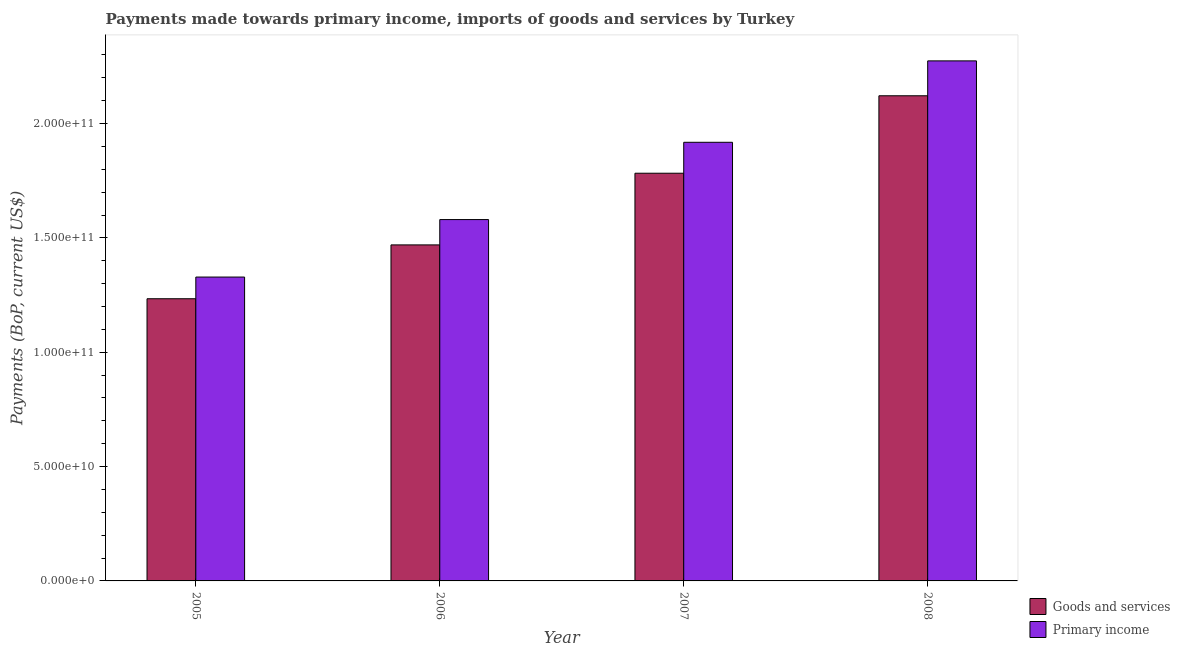How many different coloured bars are there?
Your answer should be compact. 2. How many groups of bars are there?
Make the answer very short. 4. Are the number of bars per tick equal to the number of legend labels?
Ensure brevity in your answer.  Yes. Are the number of bars on each tick of the X-axis equal?
Keep it short and to the point. Yes. How many bars are there on the 1st tick from the left?
Ensure brevity in your answer.  2. What is the label of the 3rd group of bars from the left?
Offer a terse response. 2007. What is the payments made towards goods and services in 2006?
Your answer should be very brief. 1.47e+11. Across all years, what is the maximum payments made towards primary income?
Offer a very short reply. 2.27e+11. Across all years, what is the minimum payments made towards goods and services?
Ensure brevity in your answer.  1.23e+11. In which year was the payments made towards goods and services maximum?
Provide a short and direct response. 2008. What is the total payments made towards primary income in the graph?
Provide a short and direct response. 7.10e+11. What is the difference between the payments made towards primary income in 2005 and that in 2006?
Make the answer very short. -2.51e+1. What is the difference between the payments made towards goods and services in 2006 and the payments made towards primary income in 2007?
Your answer should be compact. -3.13e+1. What is the average payments made towards goods and services per year?
Your answer should be compact. 1.65e+11. In how many years, is the payments made towards goods and services greater than 20000000000 US$?
Your response must be concise. 4. What is the ratio of the payments made towards primary income in 2005 to that in 2008?
Your response must be concise. 0.58. Is the payments made towards primary income in 2005 less than that in 2006?
Offer a terse response. Yes. Is the difference between the payments made towards goods and services in 2006 and 2007 greater than the difference between the payments made towards primary income in 2006 and 2007?
Keep it short and to the point. No. What is the difference between the highest and the second highest payments made towards primary income?
Ensure brevity in your answer.  3.56e+1. What is the difference between the highest and the lowest payments made towards primary income?
Your answer should be compact. 9.45e+1. In how many years, is the payments made towards goods and services greater than the average payments made towards goods and services taken over all years?
Your response must be concise. 2. Is the sum of the payments made towards goods and services in 2006 and 2007 greater than the maximum payments made towards primary income across all years?
Give a very brief answer. Yes. What does the 1st bar from the left in 2008 represents?
Give a very brief answer. Goods and services. What does the 2nd bar from the right in 2007 represents?
Make the answer very short. Goods and services. How many bars are there?
Keep it short and to the point. 8. How many years are there in the graph?
Offer a very short reply. 4. Are the values on the major ticks of Y-axis written in scientific E-notation?
Give a very brief answer. Yes. Does the graph contain grids?
Keep it short and to the point. No. Where does the legend appear in the graph?
Your answer should be very brief. Bottom right. How many legend labels are there?
Your response must be concise. 2. How are the legend labels stacked?
Provide a short and direct response. Vertical. What is the title of the graph?
Your answer should be compact. Payments made towards primary income, imports of goods and services by Turkey. What is the label or title of the Y-axis?
Your answer should be compact. Payments (BoP, current US$). What is the Payments (BoP, current US$) of Goods and services in 2005?
Offer a very short reply. 1.23e+11. What is the Payments (BoP, current US$) in Primary income in 2005?
Ensure brevity in your answer.  1.33e+11. What is the Payments (BoP, current US$) of Goods and services in 2006?
Offer a very short reply. 1.47e+11. What is the Payments (BoP, current US$) of Primary income in 2006?
Ensure brevity in your answer.  1.58e+11. What is the Payments (BoP, current US$) of Goods and services in 2007?
Offer a very short reply. 1.78e+11. What is the Payments (BoP, current US$) in Primary income in 2007?
Offer a terse response. 1.92e+11. What is the Payments (BoP, current US$) in Goods and services in 2008?
Your response must be concise. 2.12e+11. What is the Payments (BoP, current US$) of Primary income in 2008?
Give a very brief answer. 2.27e+11. Across all years, what is the maximum Payments (BoP, current US$) of Goods and services?
Provide a succinct answer. 2.12e+11. Across all years, what is the maximum Payments (BoP, current US$) of Primary income?
Give a very brief answer. 2.27e+11. Across all years, what is the minimum Payments (BoP, current US$) in Goods and services?
Your answer should be compact. 1.23e+11. Across all years, what is the minimum Payments (BoP, current US$) in Primary income?
Your response must be concise. 1.33e+11. What is the total Payments (BoP, current US$) of Goods and services in the graph?
Offer a very short reply. 6.61e+11. What is the total Payments (BoP, current US$) of Primary income in the graph?
Your answer should be compact. 7.10e+11. What is the difference between the Payments (BoP, current US$) in Goods and services in 2005 and that in 2006?
Provide a succinct answer. -2.35e+1. What is the difference between the Payments (BoP, current US$) of Primary income in 2005 and that in 2006?
Keep it short and to the point. -2.51e+1. What is the difference between the Payments (BoP, current US$) of Goods and services in 2005 and that in 2007?
Provide a succinct answer. -5.49e+1. What is the difference between the Payments (BoP, current US$) in Primary income in 2005 and that in 2007?
Offer a terse response. -5.89e+1. What is the difference between the Payments (BoP, current US$) of Goods and services in 2005 and that in 2008?
Provide a succinct answer. -8.88e+1. What is the difference between the Payments (BoP, current US$) in Primary income in 2005 and that in 2008?
Provide a succinct answer. -9.45e+1. What is the difference between the Payments (BoP, current US$) of Goods and services in 2006 and that in 2007?
Make the answer very short. -3.13e+1. What is the difference between the Payments (BoP, current US$) in Primary income in 2006 and that in 2007?
Provide a succinct answer. -3.38e+1. What is the difference between the Payments (BoP, current US$) in Goods and services in 2006 and that in 2008?
Your response must be concise. -6.52e+1. What is the difference between the Payments (BoP, current US$) in Primary income in 2006 and that in 2008?
Your response must be concise. -6.94e+1. What is the difference between the Payments (BoP, current US$) of Goods and services in 2007 and that in 2008?
Offer a very short reply. -3.39e+1. What is the difference between the Payments (BoP, current US$) of Primary income in 2007 and that in 2008?
Your answer should be very brief. -3.56e+1. What is the difference between the Payments (BoP, current US$) of Goods and services in 2005 and the Payments (BoP, current US$) of Primary income in 2006?
Make the answer very short. -3.46e+1. What is the difference between the Payments (BoP, current US$) of Goods and services in 2005 and the Payments (BoP, current US$) of Primary income in 2007?
Your answer should be compact. -6.84e+1. What is the difference between the Payments (BoP, current US$) of Goods and services in 2005 and the Payments (BoP, current US$) of Primary income in 2008?
Your response must be concise. -1.04e+11. What is the difference between the Payments (BoP, current US$) of Goods and services in 2006 and the Payments (BoP, current US$) of Primary income in 2007?
Keep it short and to the point. -4.49e+1. What is the difference between the Payments (BoP, current US$) of Goods and services in 2006 and the Payments (BoP, current US$) of Primary income in 2008?
Ensure brevity in your answer.  -8.05e+1. What is the difference between the Payments (BoP, current US$) in Goods and services in 2007 and the Payments (BoP, current US$) in Primary income in 2008?
Offer a terse response. -4.91e+1. What is the average Payments (BoP, current US$) in Goods and services per year?
Give a very brief answer. 1.65e+11. What is the average Payments (BoP, current US$) in Primary income per year?
Keep it short and to the point. 1.78e+11. In the year 2005, what is the difference between the Payments (BoP, current US$) in Goods and services and Payments (BoP, current US$) in Primary income?
Your response must be concise. -9.48e+09. In the year 2006, what is the difference between the Payments (BoP, current US$) in Goods and services and Payments (BoP, current US$) in Primary income?
Provide a succinct answer. -1.11e+1. In the year 2007, what is the difference between the Payments (BoP, current US$) in Goods and services and Payments (BoP, current US$) in Primary income?
Ensure brevity in your answer.  -1.35e+1. In the year 2008, what is the difference between the Payments (BoP, current US$) in Goods and services and Payments (BoP, current US$) in Primary income?
Make the answer very short. -1.53e+1. What is the ratio of the Payments (BoP, current US$) in Goods and services in 2005 to that in 2006?
Your answer should be very brief. 0.84. What is the ratio of the Payments (BoP, current US$) of Primary income in 2005 to that in 2006?
Your answer should be very brief. 0.84. What is the ratio of the Payments (BoP, current US$) in Goods and services in 2005 to that in 2007?
Provide a short and direct response. 0.69. What is the ratio of the Payments (BoP, current US$) in Primary income in 2005 to that in 2007?
Your answer should be compact. 0.69. What is the ratio of the Payments (BoP, current US$) of Goods and services in 2005 to that in 2008?
Your response must be concise. 0.58. What is the ratio of the Payments (BoP, current US$) in Primary income in 2005 to that in 2008?
Provide a succinct answer. 0.58. What is the ratio of the Payments (BoP, current US$) in Goods and services in 2006 to that in 2007?
Provide a short and direct response. 0.82. What is the ratio of the Payments (BoP, current US$) of Primary income in 2006 to that in 2007?
Give a very brief answer. 0.82. What is the ratio of the Payments (BoP, current US$) in Goods and services in 2006 to that in 2008?
Give a very brief answer. 0.69. What is the ratio of the Payments (BoP, current US$) in Primary income in 2006 to that in 2008?
Ensure brevity in your answer.  0.69. What is the ratio of the Payments (BoP, current US$) of Goods and services in 2007 to that in 2008?
Provide a succinct answer. 0.84. What is the ratio of the Payments (BoP, current US$) in Primary income in 2007 to that in 2008?
Offer a terse response. 0.84. What is the difference between the highest and the second highest Payments (BoP, current US$) in Goods and services?
Make the answer very short. 3.39e+1. What is the difference between the highest and the second highest Payments (BoP, current US$) in Primary income?
Give a very brief answer. 3.56e+1. What is the difference between the highest and the lowest Payments (BoP, current US$) in Goods and services?
Make the answer very short. 8.88e+1. What is the difference between the highest and the lowest Payments (BoP, current US$) in Primary income?
Make the answer very short. 9.45e+1. 